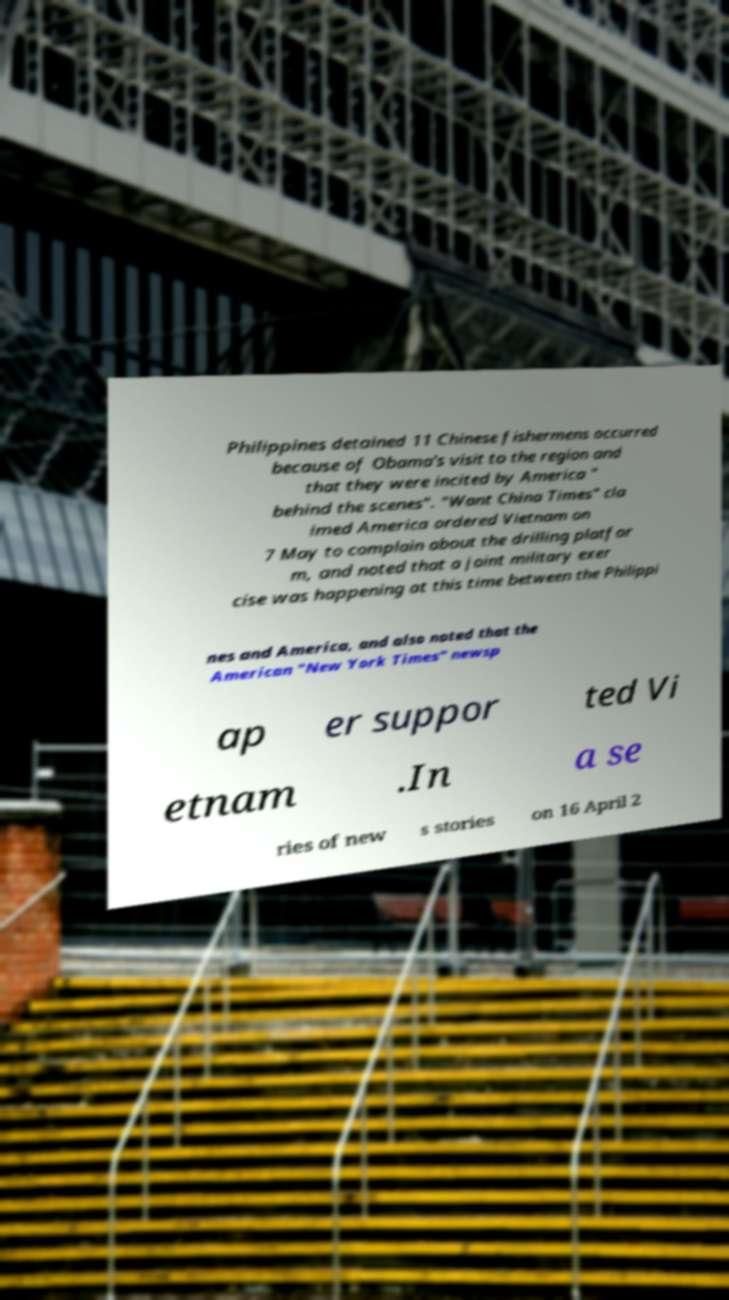Can you read and provide the text displayed in the image?This photo seems to have some interesting text. Can you extract and type it out for me? Philippines detained 11 Chinese fishermens occurred because of Obama's visit to the region and that they were incited by America " behind the scenes". "Want China Times" cla imed America ordered Vietnam on 7 May to complain about the drilling platfor m, and noted that a joint military exer cise was happening at this time between the Philippi nes and America, and also noted that the American "New York Times" newsp ap er suppor ted Vi etnam .In a se ries of new s stories on 16 April 2 